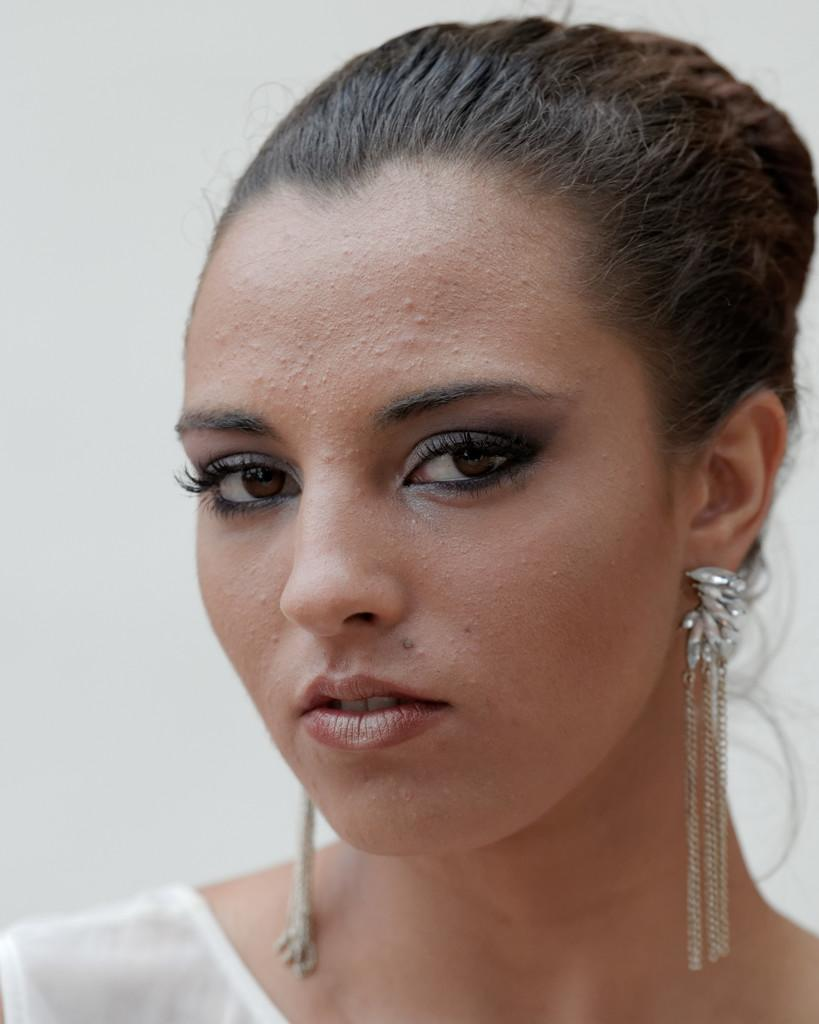Who is present in the image? There is a woman in the image. What is the woman wearing? The woman is wearing a white dress. What can be seen in the background of the image? There is a white wall in the background of the image. What type of basket is hanging from the bell in the image? There is no basket or bell present in the image; it only features a woman and a white wall in the background. 